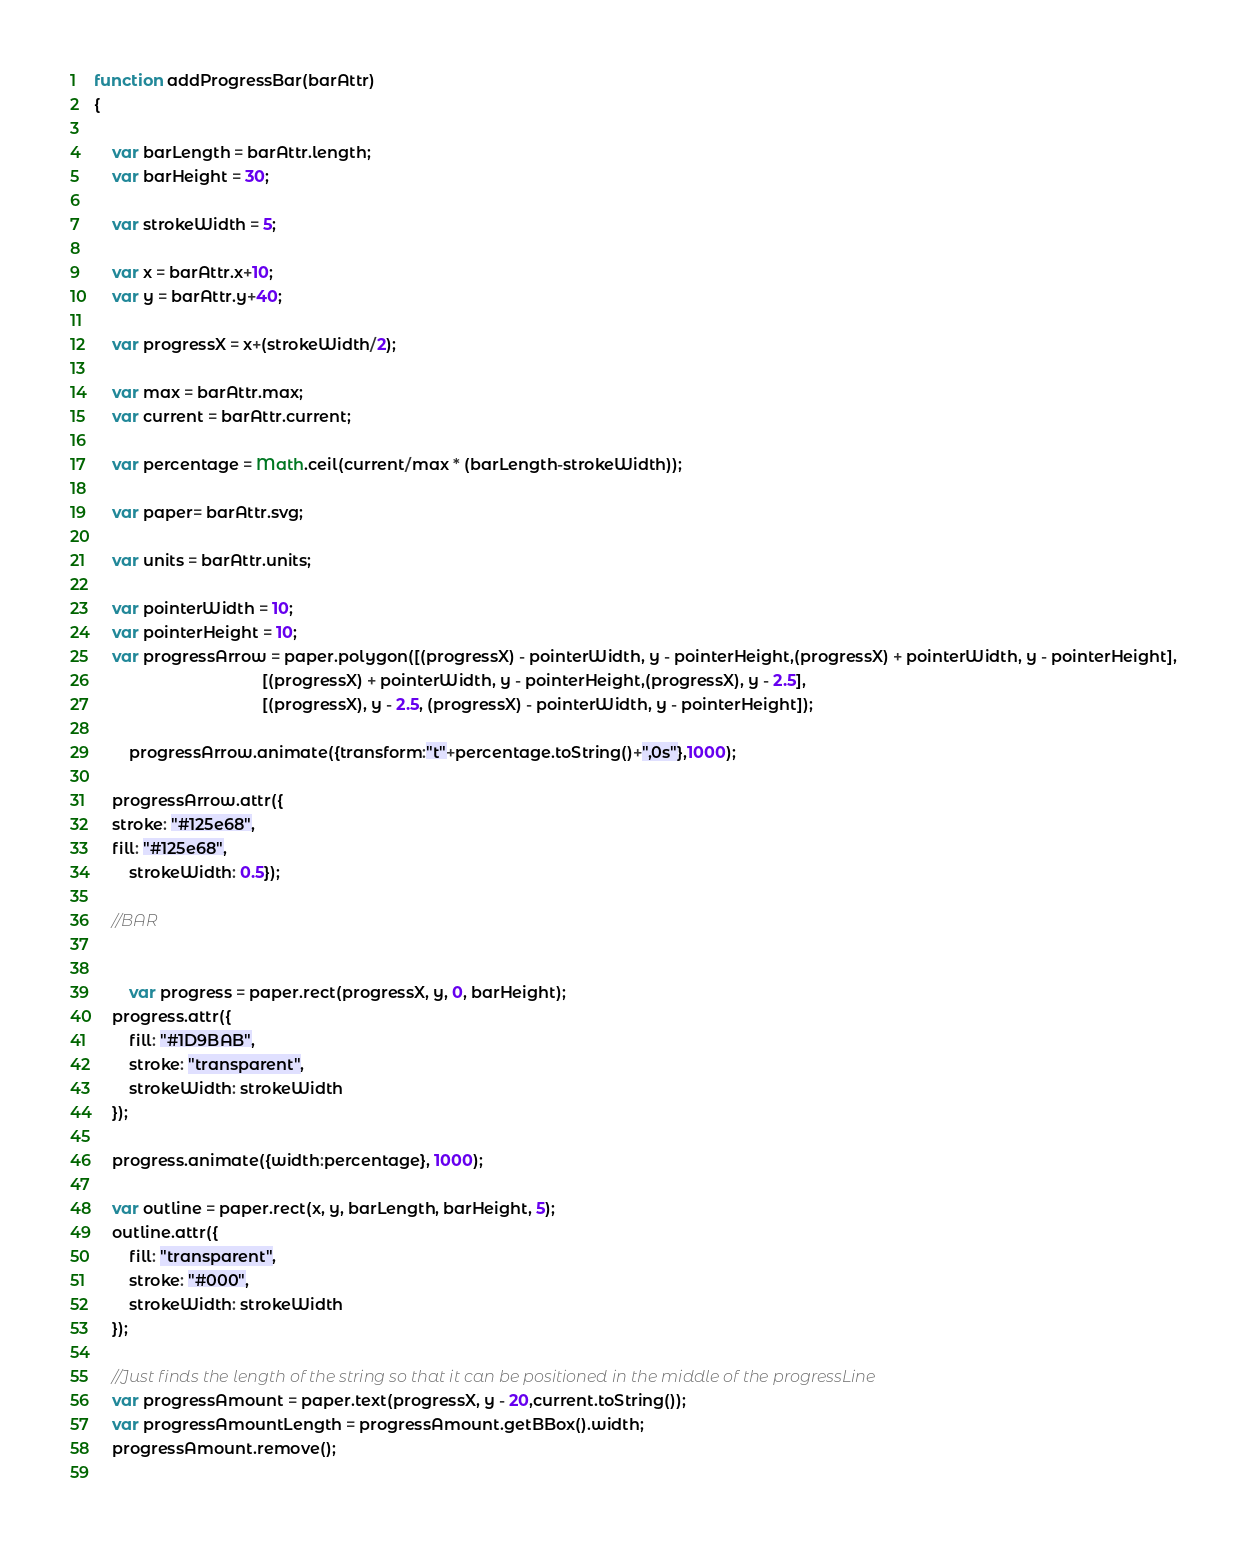<code> <loc_0><loc_0><loc_500><loc_500><_JavaScript_>function addProgressBar(barAttr)
{	
	
	var barLength = barAttr.length;
	var barHeight = 30;
	
	var strokeWidth = 5;
	
	var x = barAttr.x+10;
	var y = barAttr.y+40;
	
	var progressX = x+(strokeWidth/2);	
	
	var max = barAttr.max;
	var current = barAttr.current;		

	var percentage = Math.ceil(current/max * (barLength-strokeWidth));
	
	var paper= barAttr.svg;	

	var units = barAttr.units;
	
	var pointerWidth = 10;
	var pointerHeight = 10;
	var progressArrow = paper.polygon([(progressX) - pointerWidth, y - pointerHeight,(progressX) + pointerWidth, y - pointerHeight],
									  [(progressX) + pointerWidth, y - pointerHeight,(progressX), y - 2.5],
									  [(progressX), y - 2.5, (progressX) - pointerWidth, y - pointerHeight]);
	
		progressArrow.animate({transform:"t"+percentage.toString()+",0s"},1000);
	
	progressArrow.attr({
	stroke: "#125e68",
	fill: "#125e68",
		strokeWidth: 0.5});
		
	//BAR
	
	
		var progress = paper.rect(progressX, y, 0, barHeight);
	progress.attr({
		fill: "#1D9BAB",
		stroke: "transparent",
		strokeWidth: strokeWidth		
	});

	progress.animate({width:percentage}, 1000);

	var outline = paper.rect(x, y, barLength, barHeight, 5);
	outline.attr({
		fill: "transparent",
		stroke: "#000",
		strokeWidth: strokeWidth
	});		
	
	//Just finds the length of the string so that it can be positioned in the middle of the progressLine
	var progressAmount = paper.text(progressX, y - 20,current.toString());
	var progressAmountLength = progressAmount.getBBox().width;
	progressAmount.remove();
	</code> 